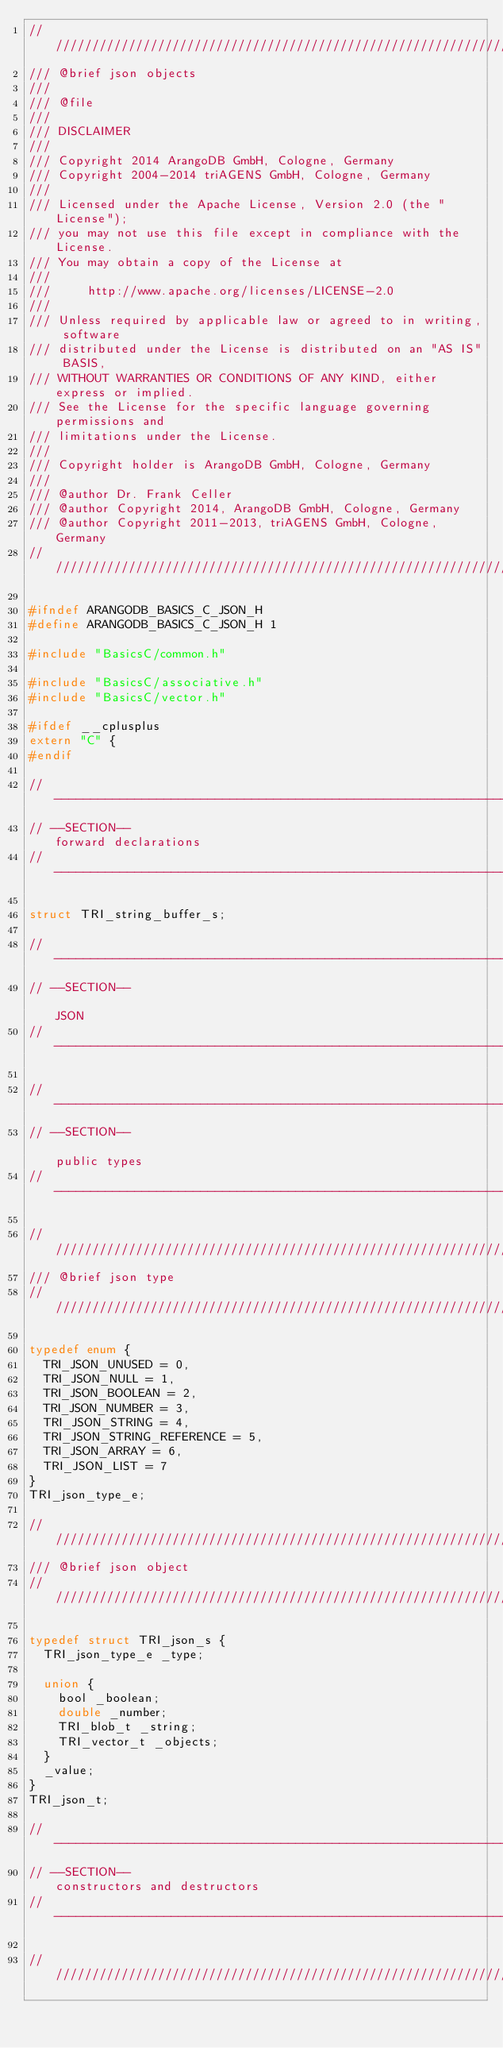<code> <loc_0><loc_0><loc_500><loc_500><_C_>////////////////////////////////////////////////////////////////////////////////
/// @brief json objects
///
/// @file
///
/// DISCLAIMER
///
/// Copyright 2014 ArangoDB GmbH, Cologne, Germany
/// Copyright 2004-2014 triAGENS GmbH, Cologne, Germany
///
/// Licensed under the Apache License, Version 2.0 (the "License");
/// you may not use this file except in compliance with the License.
/// You may obtain a copy of the License at
///
///     http://www.apache.org/licenses/LICENSE-2.0
///
/// Unless required by applicable law or agreed to in writing, software
/// distributed under the License is distributed on an "AS IS" BASIS,
/// WITHOUT WARRANTIES OR CONDITIONS OF ANY KIND, either express or implied.
/// See the License for the specific language governing permissions and
/// limitations under the License.
///
/// Copyright holder is ArangoDB GmbH, Cologne, Germany
///
/// @author Dr. Frank Celler
/// @author Copyright 2014, ArangoDB GmbH, Cologne, Germany
/// @author Copyright 2011-2013, triAGENS GmbH, Cologne, Germany
////////////////////////////////////////////////////////////////////////////////

#ifndef ARANGODB_BASICS_C_JSON_H
#define ARANGODB_BASICS_C_JSON_H 1

#include "BasicsC/common.h"

#include "BasicsC/associative.h"
#include "BasicsC/vector.h"

#ifdef __cplusplus
extern "C" {
#endif

// -----------------------------------------------------------------------------
// --SECTION--                                              forward declarations
// -----------------------------------------------------------------------------

struct TRI_string_buffer_s;

// -----------------------------------------------------------------------------
// --SECTION--                                                              JSON
// -----------------------------------------------------------------------------

// -----------------------------------------------------------------------------
// --SECTION--                                                      public types
// -----------------------------------------------------------------------------

////////////////////////////////////////////////////////////////////////////////
/// @brief json type
////////////////////////////////////////////////////////////////////////////////

typedef enum {
  TRI_JSON_UNUSED = 0,
  TRI_JSON_NULL = 1,
  TRI_JSON_BOOLEAN = 2,
  TRI_JSON_NUMBER = 3,
  TRI_JSON_STRING = 4,
  TRI_JSON_STRING_REFERENCE = 5,
  TRI_JSON_ARRAY = 6,
  TRI_JSON_LIST = 7
}
TRI_json_type_e;

////////////////////////////////////////////////////////////////////////////////
/// @brief json object
////////////////////////////////////////////////////////////////////////////////

typedef struct TRI_json_s {
  TRI_json_type_e _type;

  union {
    bool _boolean;
    double _number;
    TRI_blob_t _string;
    TRI_vector_t _objects;
  }
  _value;
}
TRI_json_t;

// -----------------------------------------------------------------------------
// --SECTION--                                      constructors and destructors
// -----------------------------------------------------------------------------

////////////////////////////////////////////////////////////////////////////////</code> 